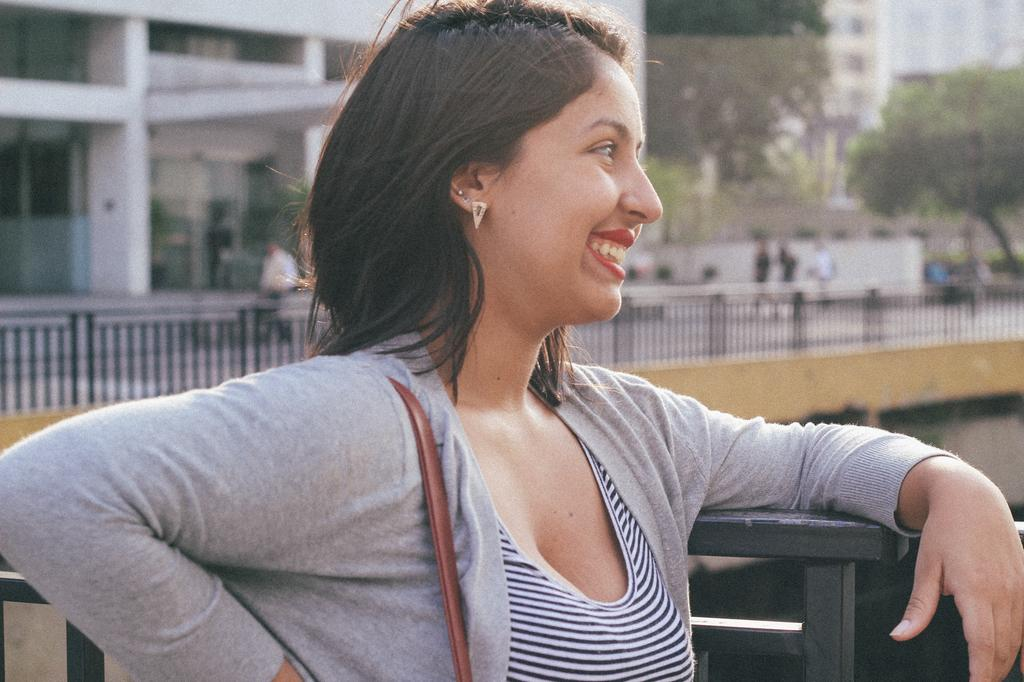Who is present in the image? There is a woman in the image. What is the woman's facial expression? The woman is smiling. What can be seen in the background of the image? There are trees, buildings, a fence, and people in the background of the image. How is the background of the image depicted? The background of the image is blurred. What type of science experiment is being conducted in the image? There is no science experiment present in the image; it features a woman smiling with a blurred background. Can you tell me how many bikes are visible in the image? There are no bikes present in the image. 